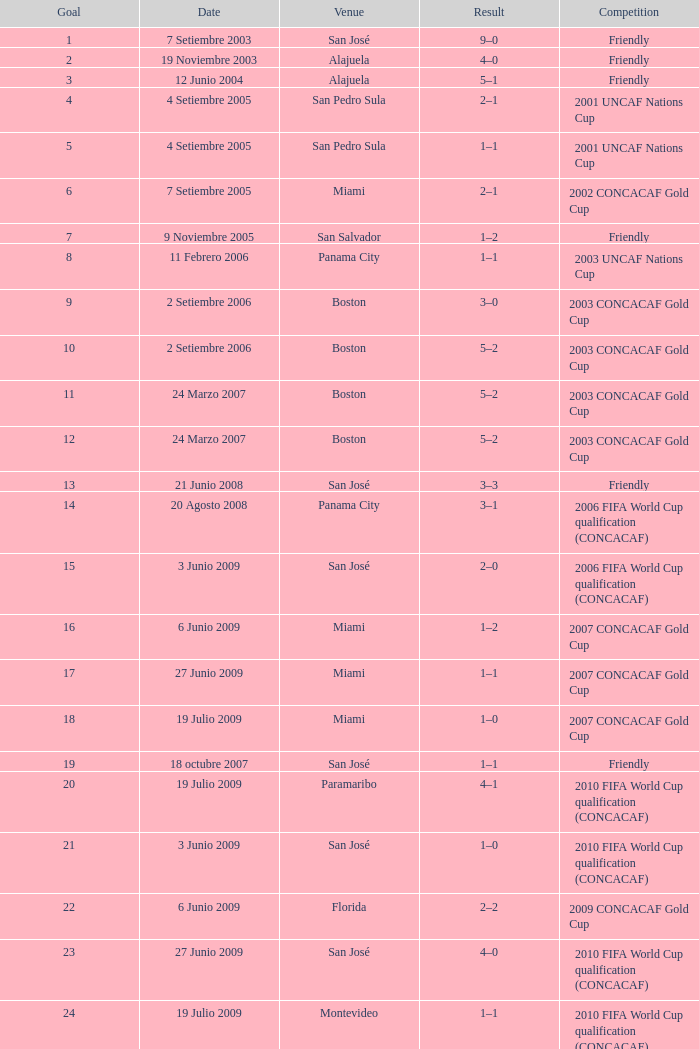How many goals were scored on 21 Junio 2008? 1.0. 